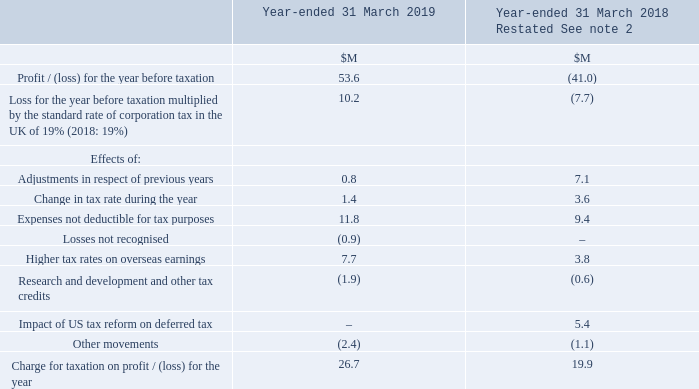The following table reconciles the theoretical corporation tax expense to the reported tax expense using the UK corporation tax rate. The reconciling items represent the impact of rate differentials in tax jurisdictions and the impact of non-taxable benefits and non-deductible expenses arising from differences between the local tax base and the reported Financial Statements.
The Group’s taxation strategy is published at www.sophos.com/en-us/medialibrary/PDFs/legal/sophos-group-tax-poli
The Group’s taxation strategy is published at www.sophos.com/en-us/medialibrary/PDFs/legal/sophos-group-tax-policyfy19. pdf and is aligned to its business strategy and operational needs. Oversight of taxation is within the remit of the Audit and Risk Committee. The Chief Financial Officer is responsible for tax strategy supported by a global team of tax professionals. Sophos strives for an open and transparent relationship with all revenue authorities and is vigilant in ensuring that the Group complies with current tax legislation. The Group proactively seeks to agree arm’s length pricing with tax authorities to mitigate tax risks of significant cross-border operations. The Group actively engages with policy makers, tax administrators, industry bodies and international institutions to provide informed input on proposed tax measures, so that it and they can understand how those proposals would affect the Group. However, a tax authority may seek adjustment to the filing position adopted by a Group company and it is accepted that interpretation of complex regulations may lead to additional tax being assessed. Uncertain tax positions are monitored regularly and a provision made in the accounts where appropriate.
What do the reconciling items in the table represent? The impact of rate differentials in tax jurisdictions and the impact of non-taxable benefits and non-deductible expenses arising from differences between the local tax base and the reported financial statements. What is the Chief Financial Officer responsible for? Responsible for tax strategy supported by a global team of tax professionals. sophos strives for an open and transparent relationship with all revenue authorities and is vigilant in ensuring that the group complies with current tax legislation. In which years was the Charge for taxation on profit for the year recorded? 2019, 2018. In which year was the Charge for taxation on profit  for the year larger? 26.7>19.9
Answer: 2019. What was the change in the Charge for taxation on profit  for the year in 2019 from 2018?
Answer scale should be: million. 26.7-19.9
Answer: 6.8. What was the percentage change in the Charge for taxation on profit for the year in 2019 from 2018?
Answer scale should be: percent. (26.7-19.9)/19.9
Answer: 34.17. 